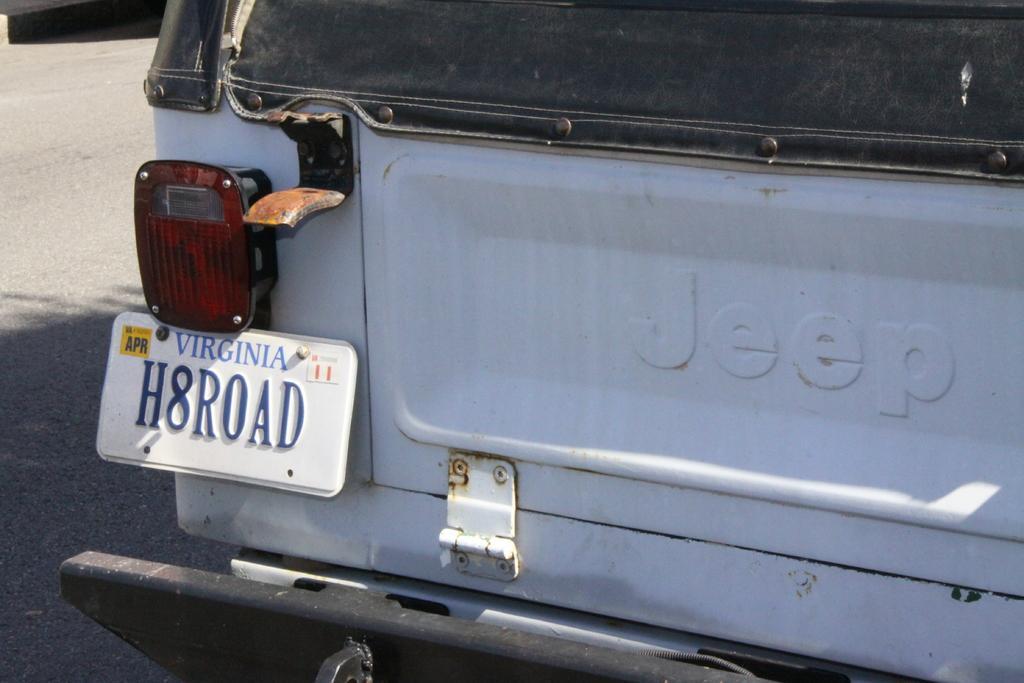Can you describe this image briefly? In this picture I can see a vehicle in front on which there is a word written and on the left side of this picture I can see a board on which there is a word, alphabets and a number written. On the left side of this image I see the road. 